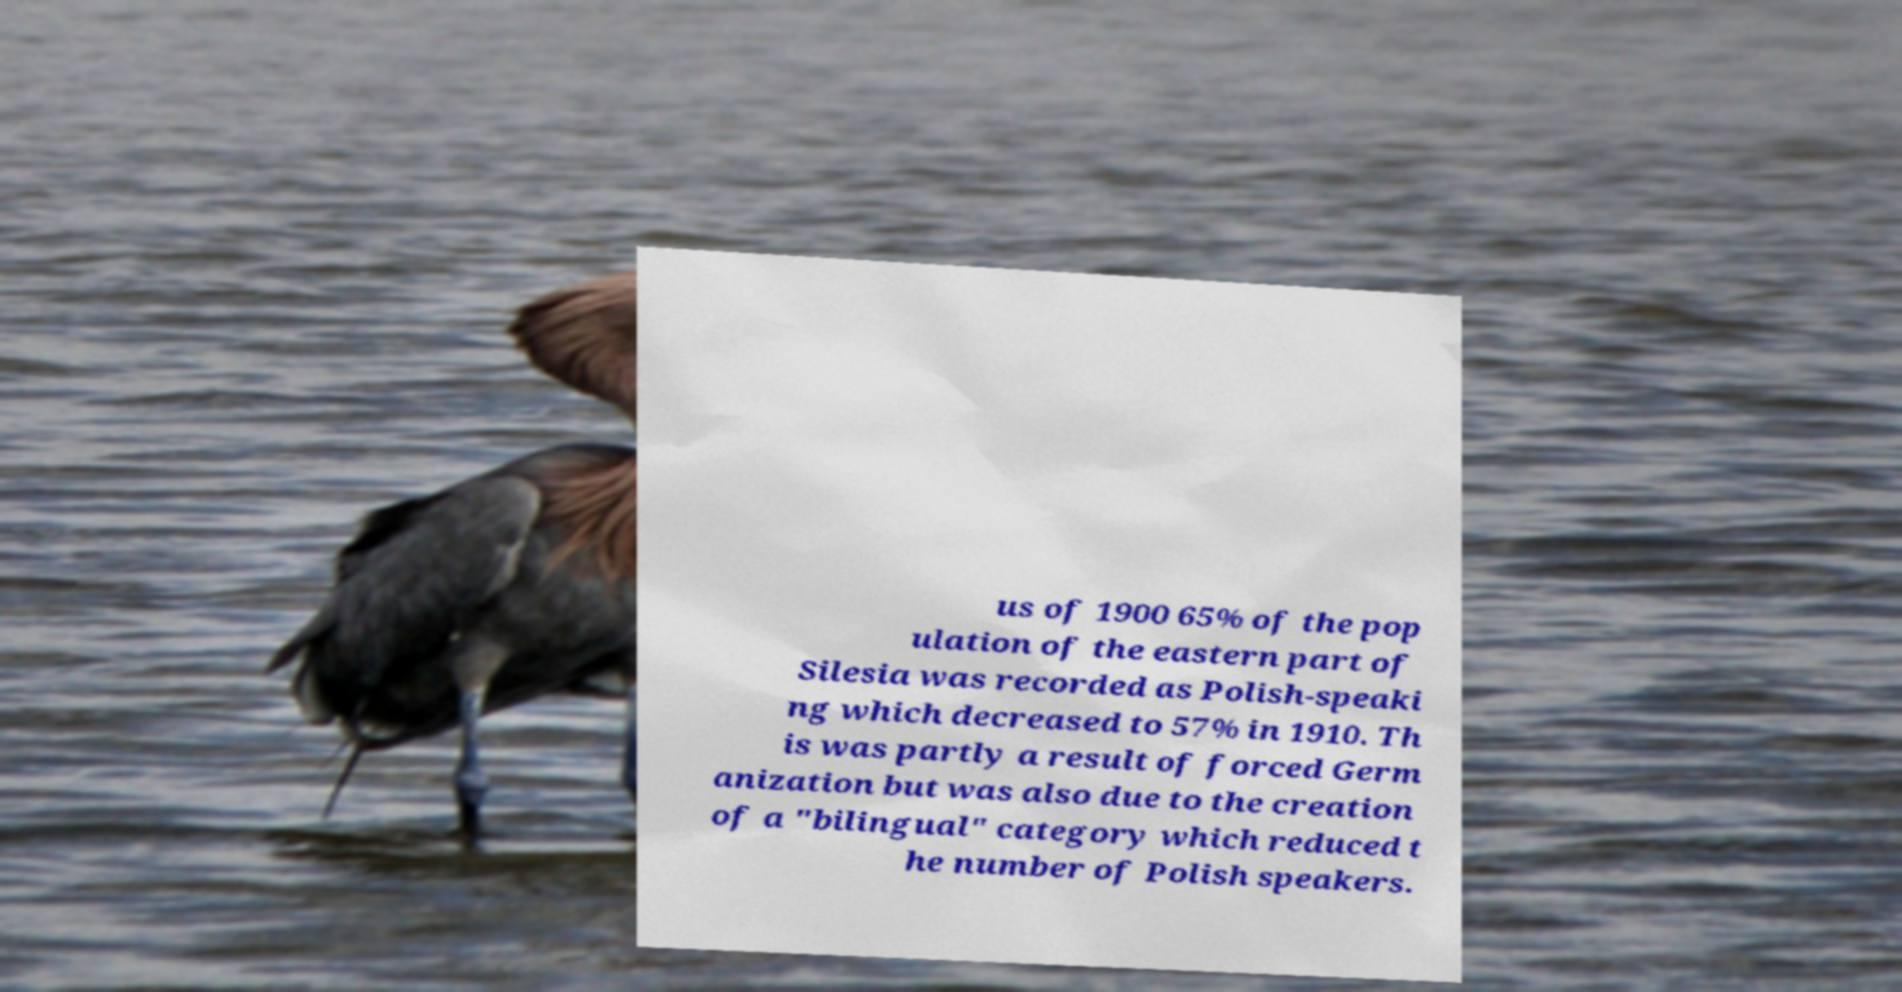Please identify and transcribe the text found in this image. us of 1900 65% of the pop ulation of the eastern part of Silesia was recorded as Polish-speaki ng which decreased to 57% in 1910. Th is was partly a result of forced Germ anization but was also due to the creation of a "bilingual" category which reduced t he number of Polish speakers. 